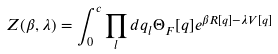<formula> <loc_0><loc_0><loc_500><loc_500>Z ( \beta , \lambda ) = \int _ { 0 } ^ { c } \prod _ { l } d q _ { l } \Theta _ { F } [ q ] e ^ { \beta R [ q ] - \lambda V [ q ] }</formula> 